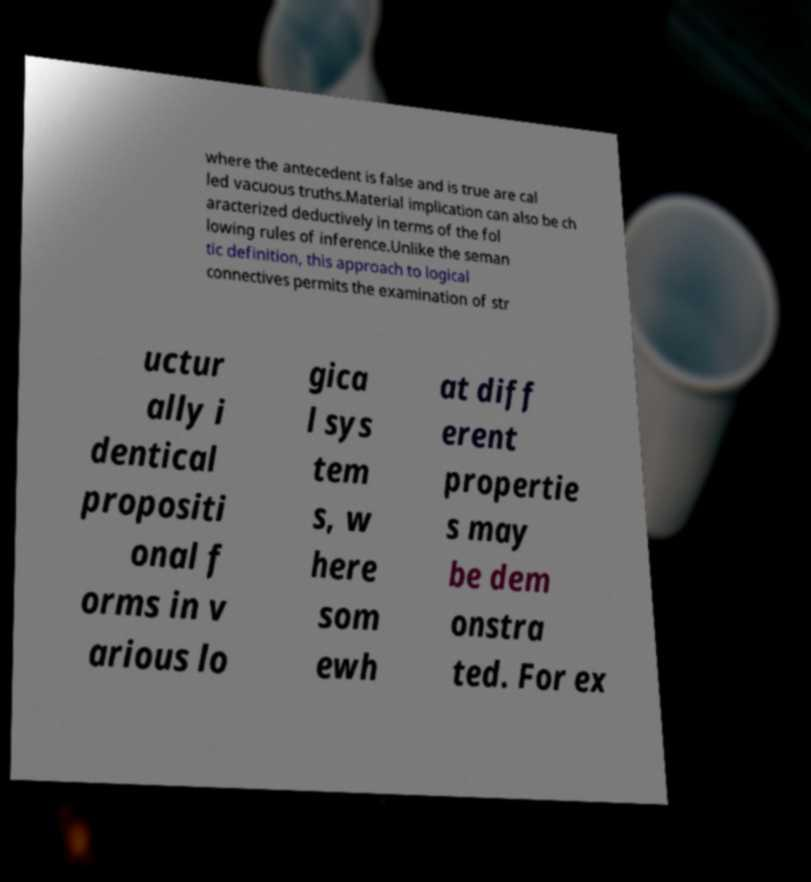For documentation purposes, I need the text within this image transcribed. Could you provide that? where the antecedent is false and is true are cal led vacuous truths.Material implication can also be ch aracterized deductively in terms of the fol lowing rules of inference.Unlike the seman tic definition, this approach to logical connectives permits the examination of str uctur ally i dentical propositi onal f orms in v arious lo gica l sys tem s, w here som ewh at diff erent propertie s may be dem onstra ted. For ex 